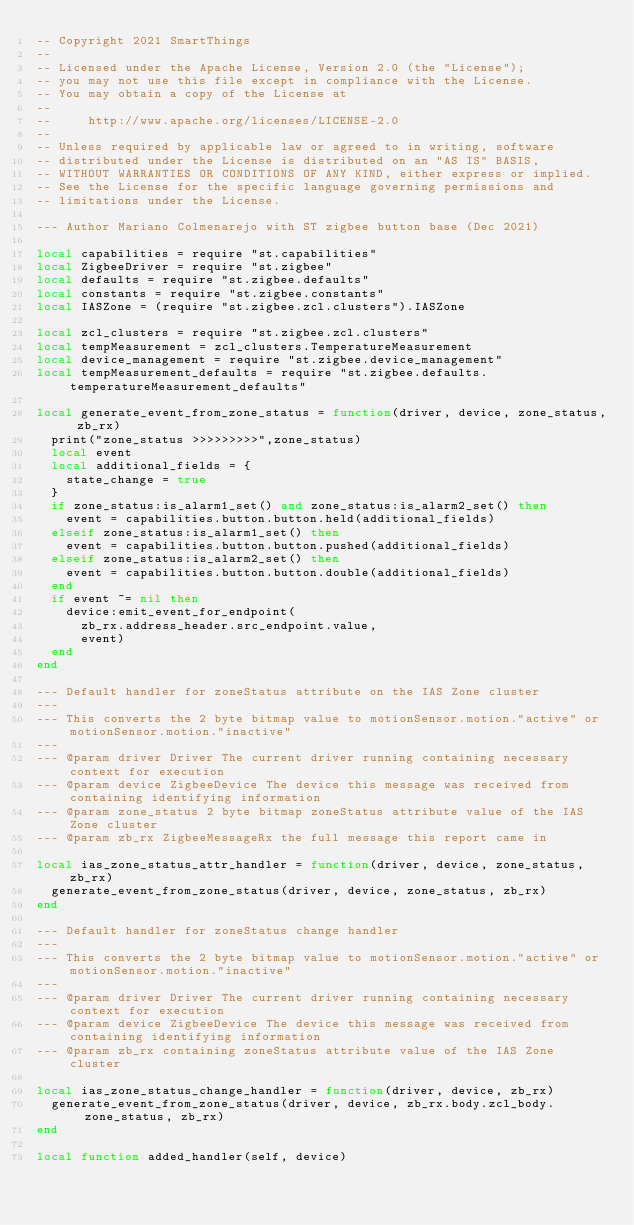<code> <loc_0><loc_0><loc_500><loc_500><_Lua_>-- Copyright 2021 SmartThings
--
-- Licensed under the Apache License, Version 2.0 (the "License");
-- you may not use this file except in compliance with the License.
-- You may obtain a copy of the License at
--
--     http://www.apache.org/licenses/LICENSE-2.0
--
-- Unless required by applicable law or agreed to in writing, software
-- distributed under the License is distributed on an "AS IS" BASIS,
-- WITHOUT WARRANTIES OR CONDITIONS OF ANY KIND, either express or implied.
-- See the License for the specific language governing permissions and
-- limitations under the License.

--- Author Mariano Colmenarejo with ST zigbee button base (Dec 2021)

local capabilities = require "st.capabilities"
local ZigbeeDriver = require "st.zigbee"
local defaults = require "st.zigbee.defaults"
local constants = require "st.zigbee.constants"
local IASZone = (require "st.zigbee.zcl.clusters").IASZone

local zcl_clusters = require "st.zigbee.zcl.clusters"
local tempMeasurement = zcl_clusters.TemperatureMeasurement
local device_management = require "st.zigbee.device_management"
local tempMeasurement_defaults = require "st.zigbee.defaults.temperatureMeasurement_defaults"

local generate_event_from_zone_status = function(driver, device, zone_status, zb_rx)
  print("zone_status >>>>>>>>>",zone_status)
  local event
  local additional_fields = {
    state_change = true
  }
  if zone_status:is_alarm1_set() and zone_status:is_alarm2_set() then
    event = capabilities.button.button.held(additional_fields)
  elseif zone_status:is_alarm1_set() then
    event = capabilities.button.button.pushed(additional_fields)
  elseif zone_status:is_alarm2_set() then
    event = capabilities.button.button.double(additional_fields)
  end
  if event ~= nil then
    device:emit_event_for_endpoint(
      zb_rx.address_header.src_endpoint.value,
      event)
  end
end

--- Default handler for zoneStatus attribute on the IAS Zone cluster
---
--- This converts the 2 byte bitmap value to motionSensor.motion."active" or motionSensor.motion."inactive"
---
--- @param driver Driver The current driver running containing necessary context for execution
--- @param device ZigbeeDevice The device this message was received from containing identifying information
--- @param zone_status 2 byte bitmap zoneStatus attribute value of the IAS Zone cluster
--- @param zb_rx ZigbeeMessageRx the full message this report came in

local ias_zone_status_attr_handler = function(driver, device, zone_status, zb_rx)
  generate_event_from_zone_status(driver, device, zone_status, zb_rx)
end

--- Default handler for zoneStatus change handler
---
--- This converts the 2 byte bitmap value to motionSensor.motion."active" or motionSensor.motion."inactive"
---
--- @param driver Driver The current driver running containing necessary context for execution
--- @param device ZigbeeDevice The device this message was received from containing identifying information
--- @param zb_rx containing zoneStatus attribute value of the IAS Zone cluster

local ias_zone_status_change_handler = function(driver, device, zb_rx)
  generate_event_from_zone_status(driver, device, zb_rx.body.zcl_body.zone_status, zb_rx)
end

local function added_handler(self, device)</code> 